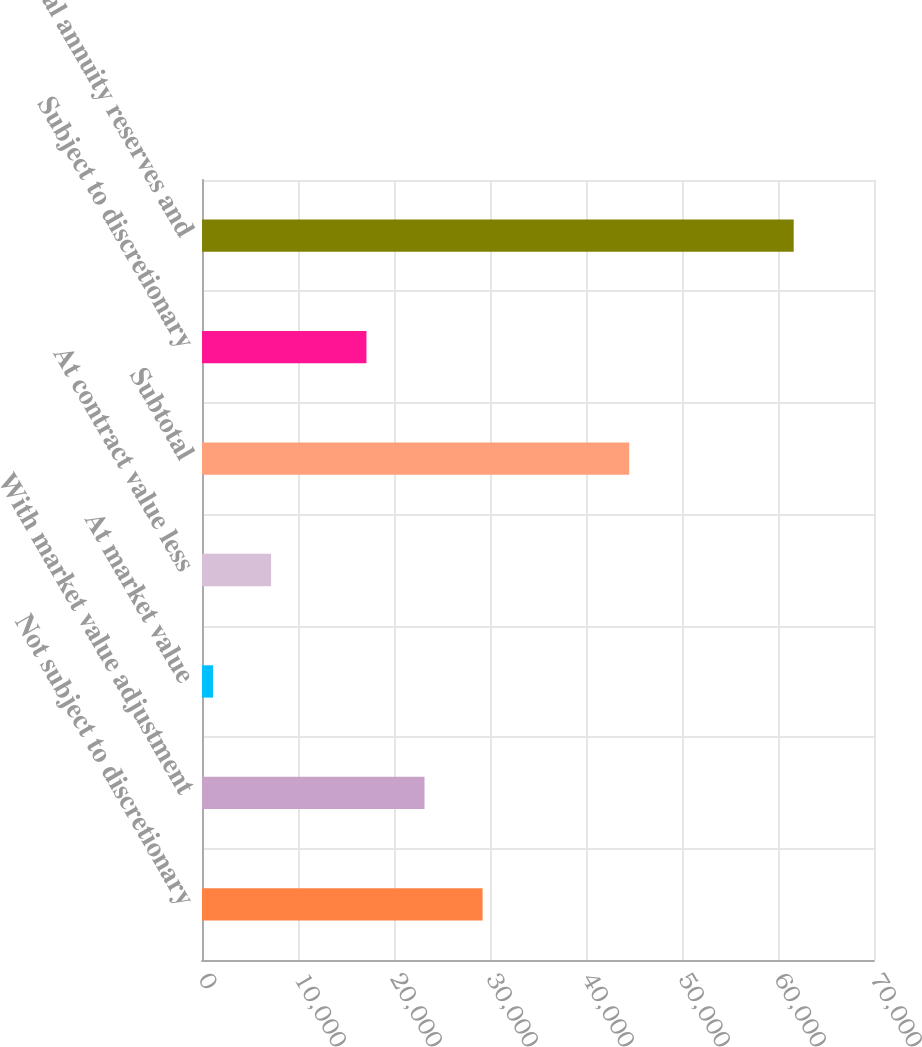Convert chart. <chart><loc_0><loc_0><loc_500><loc_500><bar_chart><fcel>Not subject to discretionary<fcel>With market value adjustment<fcel>At market value<fcel>At contract value less<fcel>Subtotal<fcel>Subject to discretionary<fcel>Total annuity reserves and<nl><fcel>29227.4<fcel>23178.7<fcel>1146<fcel>7194.7<fcel>44503<fcel>17130<fcel>61633<nl></chart> 